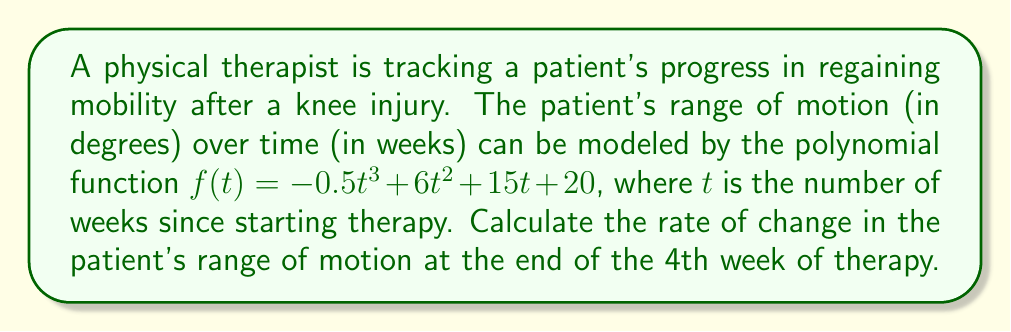Can you answer this question? To find the rate of change in the patient's range of motion at a specific point in time, we need to calculate the derivative of the given function and evaluate it at the desired point.

1. Given function: $f(t) = -0.5t^3 + 6t^2 + 15t + 20$

2. Calculate the derivative:
   $f'(t) = \frac{d}{dt}(-0.5t^3 + 6t^2 + 15t + 20)$
   $f'(t) = -1.5t^2 + 12t + 15$

3. Evaluate the derivative at $t = 4$ (end of 4th week):
   $f'(4) = -1.5(4^2) + 12(4) + 15$
   $f'(4) = -1.5(16) + 48 + 15$
   $f'(4) = -24 + 48 + 15$
   $f'(4) = 39$

The rate of change at $t = 4$ is 39 degrees per week.
Answer: 39 degrees per week 